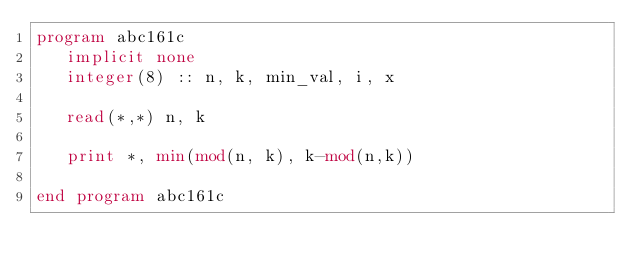<code> <loc_0><loc_0><loc_500><loc_500><_FORTRAN_>program abc161c
   implicit none
   integer(8) :: n, k, min_val, i, x

   read(*,*) n, k

   print *, min(mod(n, k), k-mod(n,k))

end program abc161c
</code> 